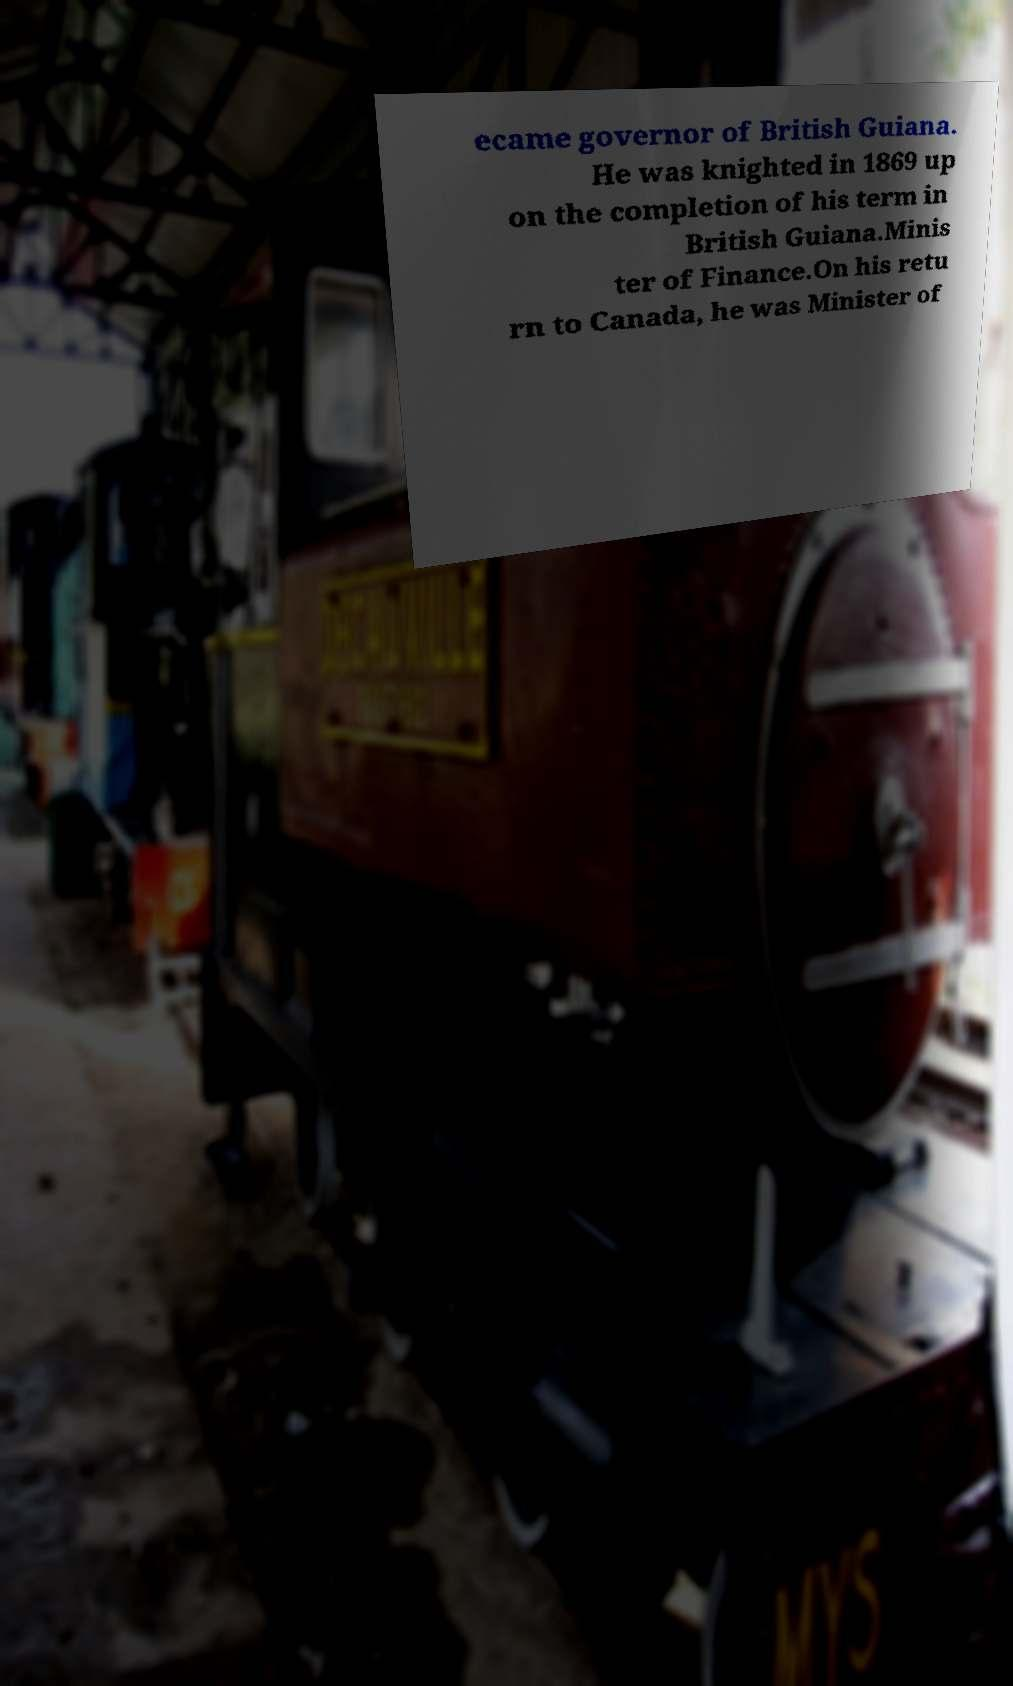There's text embedded in this image that I need extracted. Can you transcribe it verbatim? ecame governor of British Guiana. He was knighted in 1869 up on the completion of his term in British Guiana.Minis ter of Finance.On his retu rn to Canada, he was Minister of 